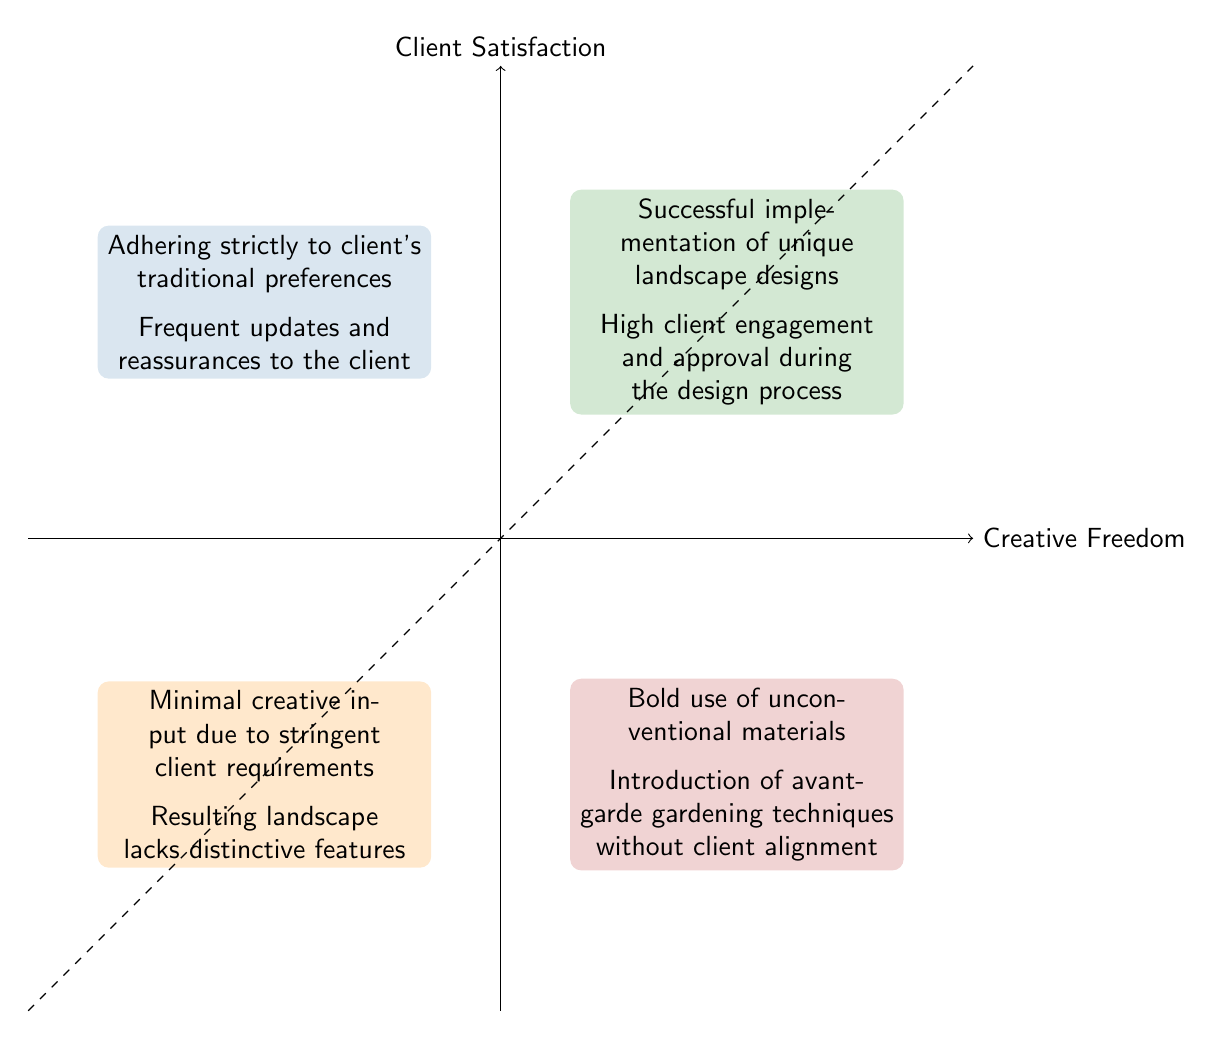What are the contents of the high-freedom, high-satisfaction quadrant? The high-freedom, high-satisfaction quadrant contains: "Successful implementation of unique landscape designs" and "High client engagement and approval during the design process."
Answer: Successful implementation of unique landscape designs, High client engagement and approval during the design process What are the contents of the low-freedom, low-satisfaction quadrant? The low-freedom, low-satisfaction quadrant features: "Minimal creative input due to stringent client requirements" and "Resulting landscape lacks distinctive features."
Answer: Minimal creative input due to stringent client requirements, Resulting landscape lacks distinctive features Which quadrant relates to strict adherence to client's preferences? The quadrant that relates to strict adherence to client's preferences is the low-freedom, high-satisfaction quadrant.
Answer: low-freedom, high-satisfaction How many quadrants are shown in the diagram? There are four quadrants shown in the diagram. Each quadrant represents a different relationship between creative freedom and client satisfaction.
Answer: 4 Which quadrant indicates the most risk in terms of client satisfaction? The high-freedom, low-satisfaction quadrant represents the most risk, as it indicates that despite creative freedom, client satisfaction is low.
Answer: high-freedom, low-satisfaction What is the relationship between creative freedom and client satisfaction in the low-freedom, high-satisfaction quadrant? In the low-freedom, high-satisfaction quadrant, client satisfaction is high, but creative freedom is low, indicating that meeting client preferences leads to satisfaction.
Answer: High satisfaction, low freedom Which quadrant would you find innovative landscape designs? Innovative landscape designs would be found in the high-freedom, high-satisfaction quadrant, where unique designs are successful and clients are engaged.
Answer: high-freedom, high-satisfaction In the diagram, how does client satisfaction change from the low-freedom, high-satisfaction quadrant to the high-freedom, low-satisfaction quadrant? Moving from the low-freedom, high-satisfaction quadrant to the high-freedom, low-satisfaction quadrant, client satisfaction decreases while creative freedom increases.
Answer: Decreases 